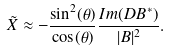<formula> <loc_0><loc_0><loc_500><loc_500>\tilde { X } \approx - \frac { \sin ^ { 2 } ( \theta ) } { \cos ( \theta ) } \frac { I m ( D B ^ { * } ) } { | B | ^ { 2 } } .</formula> 